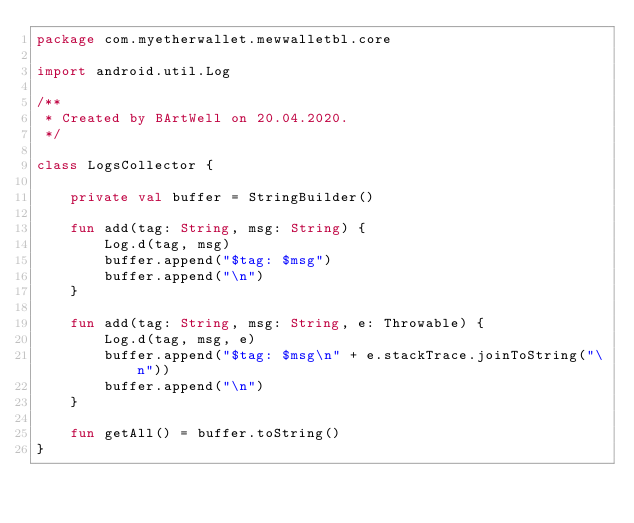<code> <loc_0><loc_0><loc_500><loc_500><_Kotlin_>package com.myetherwallet.mewwalletbl.core

import android.util.Log

/**
 * Created by BArtWell on 20.04.2020.
 */

class LogsCollector {

    private val buffer = StringBuilder()

    fun add(tag: String, msg: String) {
        Log.d(tag, msg)
        buffer.append("$tag: $msg")
        buffer.append("\n")
    }

    fun add(tag: String, msg: String, e: Throwable) {
        Log.d(tag, msg, e)
        buffer.append("$tag: $msg\n" + e.stackTrace.joinToString("\n"))
        buffer.append("\n")
    }

    fun getAll() = buffer.toString()
}
</code> 